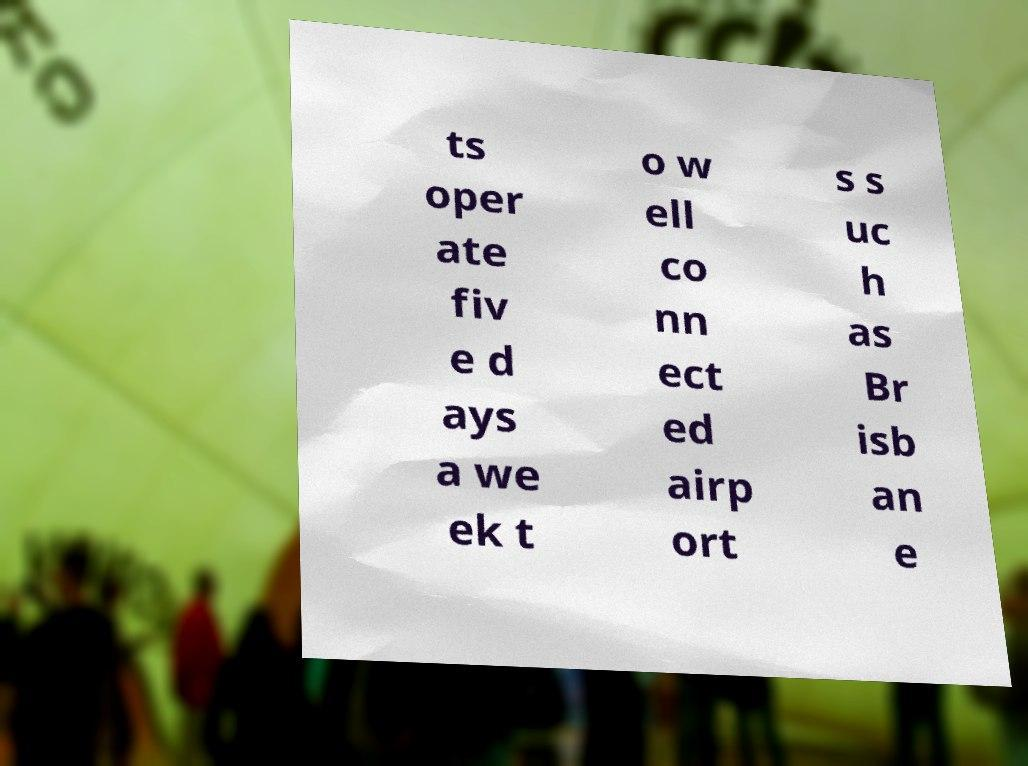There's text embedded in this image that I need extracted. Can you transcribe it verbatim? ts oper ate fiv e d ays a we ek t o w ell co nn ect ed airp ort s s uc h as Br isb an e 